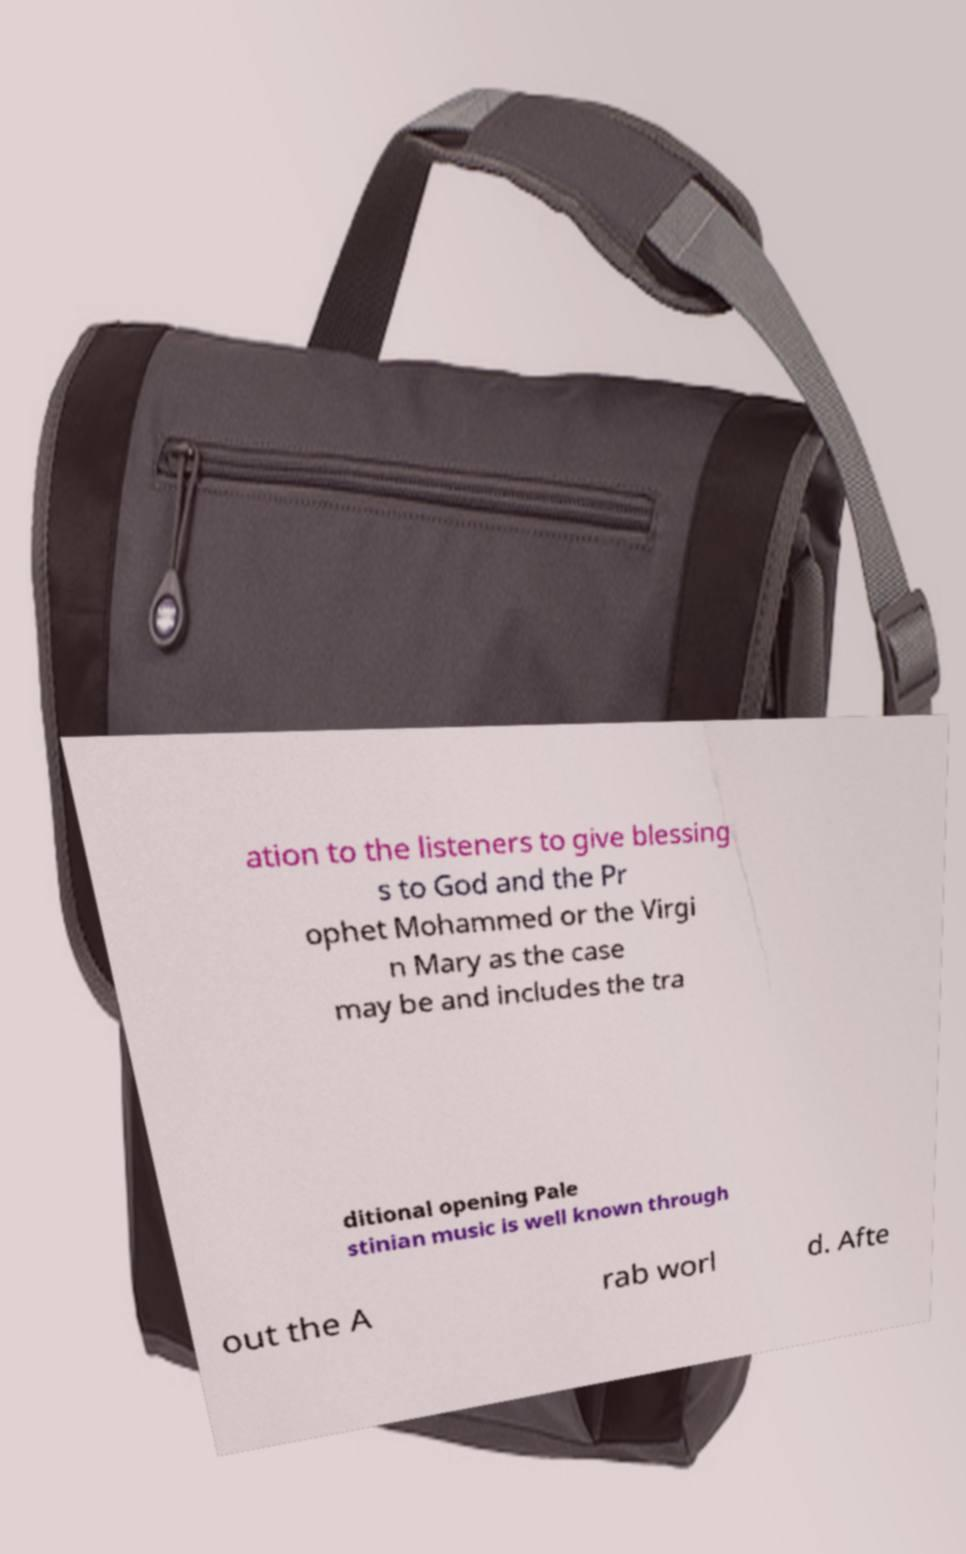Please identify and transcribe the text found in this image. ation to the listeners to give blessing s to God and the Pr ophet Mohammed or the Virgi n Mary as the case may be and includes the tra ditional opening Pale stinian music is well known through out the A rab worl d. Afte 